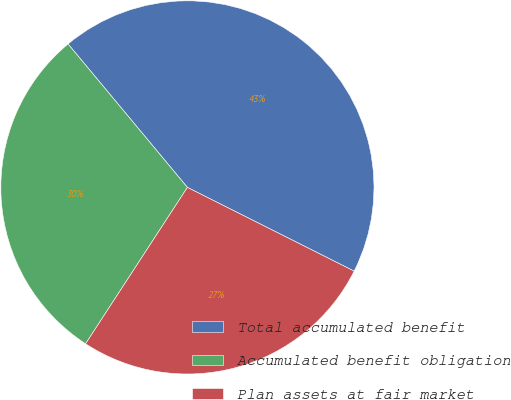Convert chart. <chart><loc_0><loc_0><loc_500><loc_500><pie_chart><fcel>Total accumulated benefit<fcel>Accumulated benefit obligation<fcel>Plan assets at fair market<nl><fcel>43.45%<fcel>29.77%<fcel>26.78%<nl></chart> 